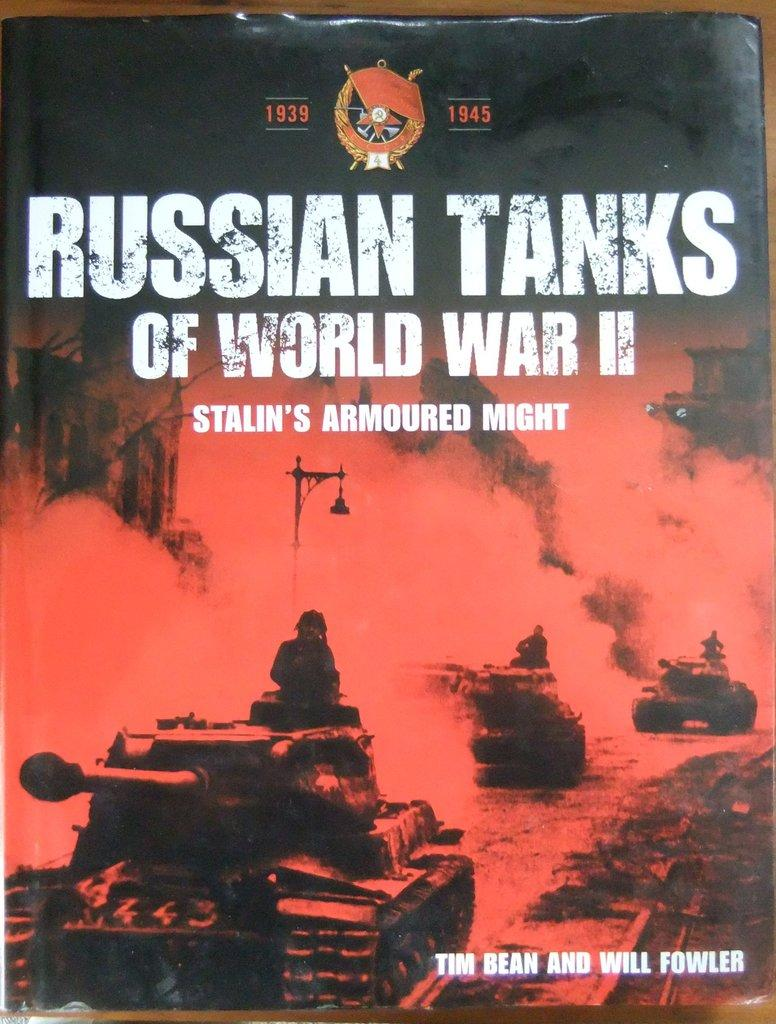What is the main subject of the image? The main subject of the image is the cover page of a book. What is the cover page placed on? The cover page is on a brown surface. What types of objects or characters can be seen on the cover page? There are people and vehicles depicted on the cover page. What additional element is present on the cover page? There is smoke depicted on the cover page. Is there any text on the cover page? Yes, there is text written on the cover page. What type of quilt is being used to cover the vehicles on the cover page? There is no quilt present in the image; it features a cover page of a book with people, vehicles, smoke, and text. What government policy is depicted on the cover page? There is no reference to any government policy on the cover page; it primarily depicts people, vehicles, smoke, and text. 